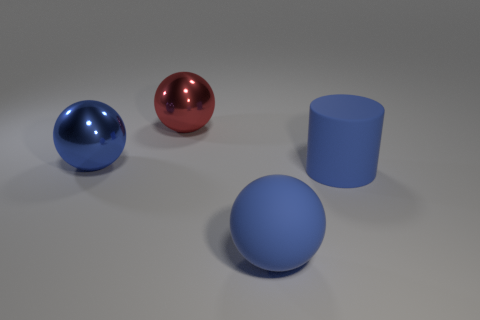Add 4 tiny cyan cylinders. How many objects exist? 8 Subtract all cylinders. How many objects are left? 3 Subtract all small red shiny things. Subtract all large metallic balls. How many objects are left? 2 Add 3 blue matte objects. How many blue matte objects are left? 5 Add 4 blue shiny things. How many blue shiny things exist? 5 Subtract 0 cyan spheres. How many objects are left? 4 